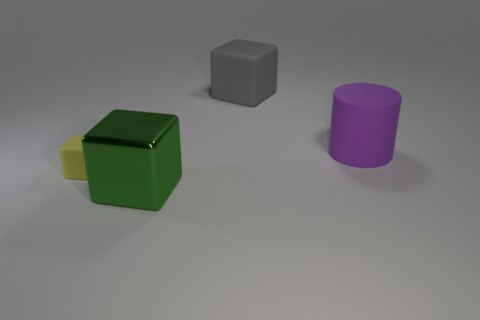Add 2 big objects. How many objects exist? 6 Subtract all cubes. How many objects are left? 1 Subtract all yellow blocks. Subtract all cylinders. How many objects are left? 2 Add 4 tiny yellow matte cubes. How many tiny yellow matte cubes are left? 5 Add 3 green things. How many green things exist? 4 Subtract 0 blue cubes. How many objects are left? 4 